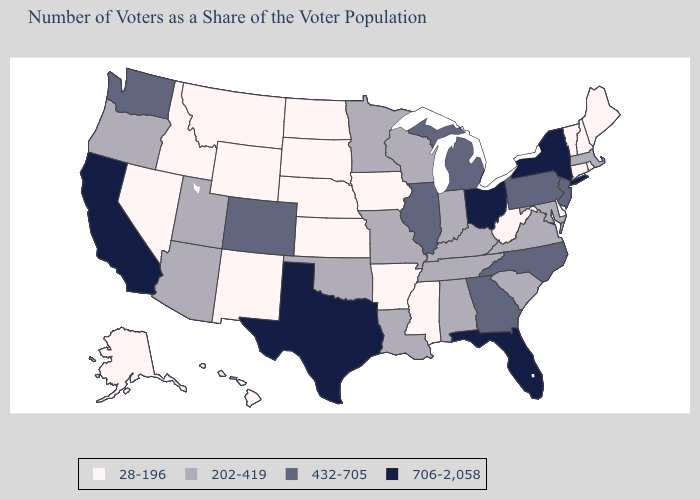Does New Jersey have the lowest value in the Northeast?
Concise answer only. No. What is the value of Oregon?
Keep it brief. 202-419. Name the states that have a value in the range 706-2,058?
Be succinct. California, Florida, New York, Ohio, Texas. Does Texas have the highest value in the USA?
Quick response, please. Yes. Name the states that have a value in the range 432-705?
Concise answer only. Colorado, Georgia, Illinois, Michigan, New Jersey, North Carolina, Pennsylvania, Washington. Which states have the lowest value in the MidWest?
Keep it brief. Iowa, Kansas, Nebraska, North Dakota, South Dakota. What is the highest value in states that border Maine?
Write a very short answer. 28-196. Does the first symbol in the legend represent the smallest category?
Answer briefly. Yes. Which states hav the highest value in the Northeast?
Short answer required. New York. Among the states that border Florida , does Georgia have the lowest value?
Answer briefly. No. What is the value of Colorado?
Short answer required. 432-705. Which states hav the highest value in the West?
Write a very short answer. California. Does Texas have the highest value in the South?
Concise answer only. Yes. What is the value of Oregon?
Keep it brief. 202-419. Does Illinois have the highest value in the MidWest?
Quick response, please. No. 